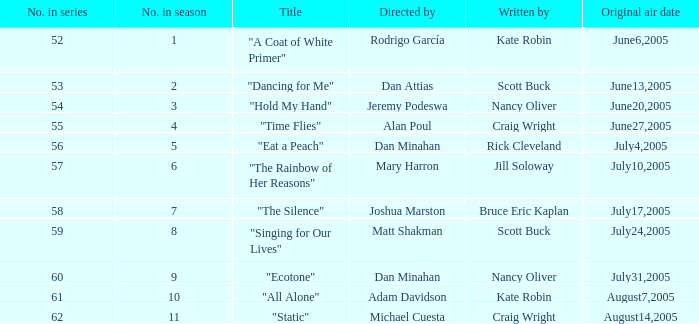What is the number of the episode in the season that has nancy oliver as the writer? 9.0. 